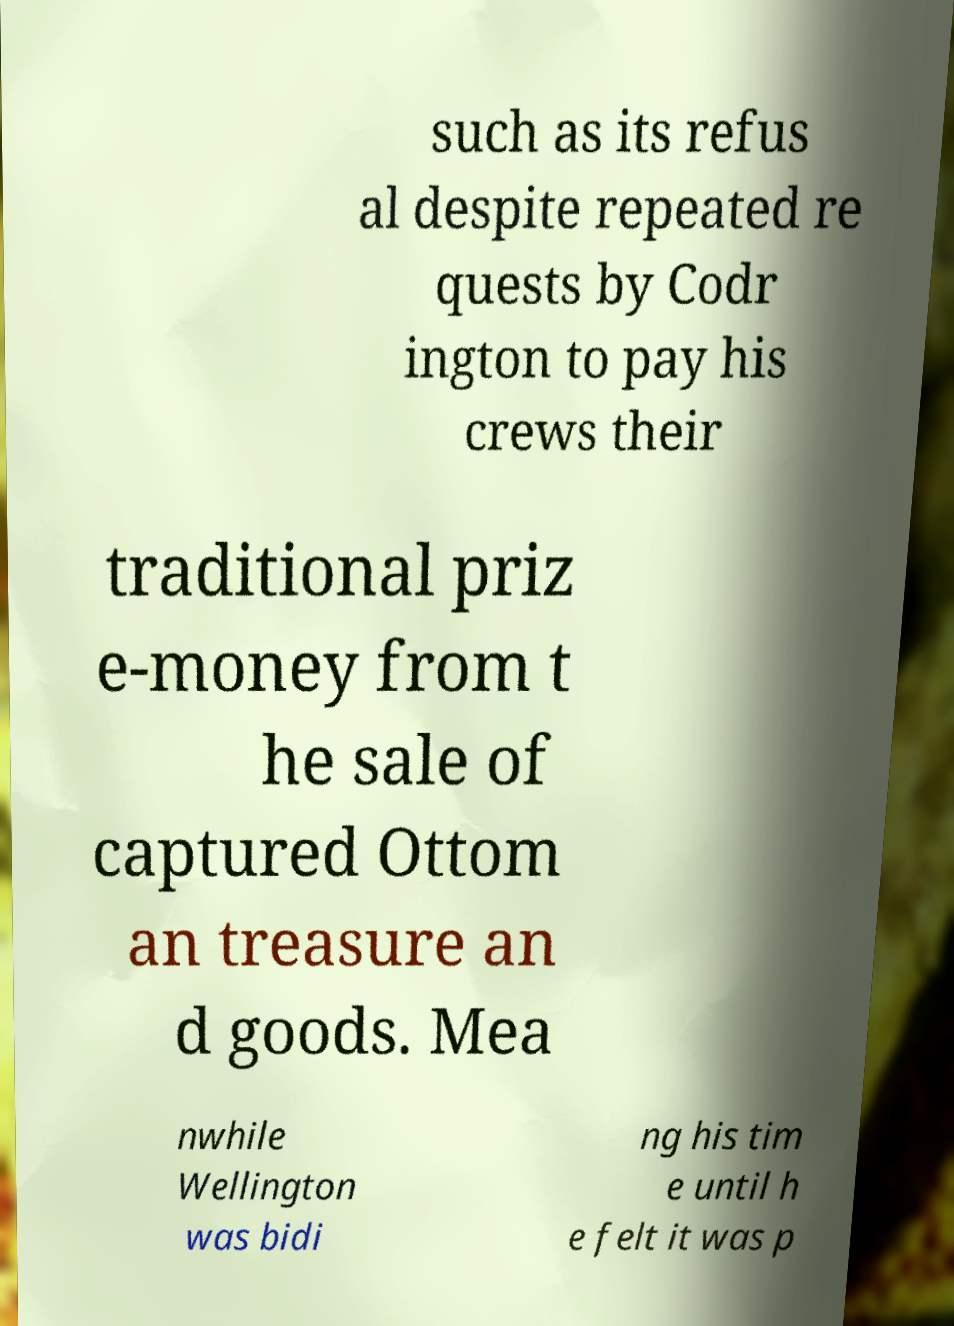Can you accurately transcribe the text from the provided image for me? such as its refus al despite repeated re quests by Codr ington to pay his crews their traditional priz e-money from t he sale of captured Ottom an treasure an d goods. Mea nwhile Wellington was bidi ng his tim e until h e felt it was p 